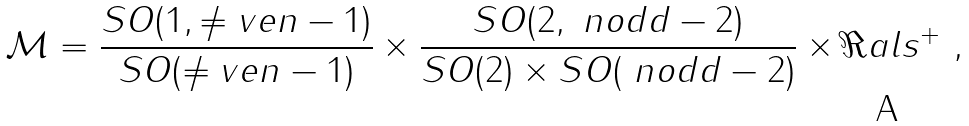<formula> <loc_0><loc_0><loc_500><loc_500>\mathcal { M } = \frac { S O ( 1 , \ne v e n - 1 ) } { S O ( \ne v e n - 1 ) } \times \frac { S O ( 2 , \ n o d d - 2 ) } { S O ( 2 ) \times S O ( \ n o d d - 2 ) } \times \Re a l s ^ { + } \ ,</formula> 